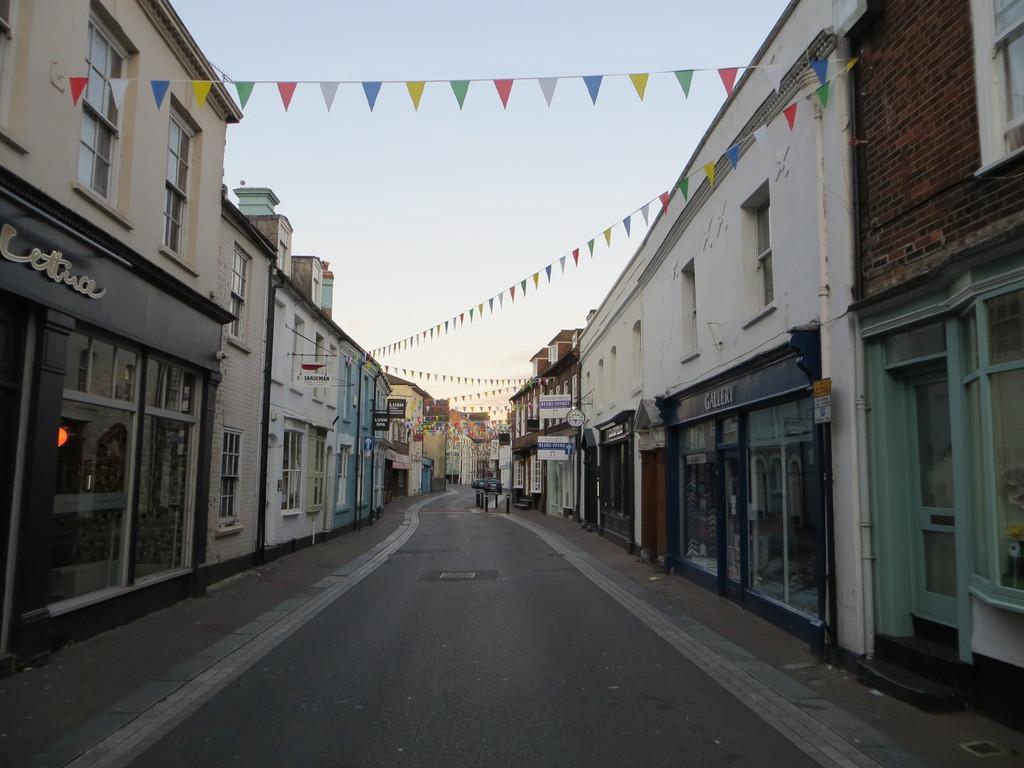Can you describe this image briefly? In this image we can see many buildings. Image also consists of flags. At the top there is sky and at the bottom there is road. 